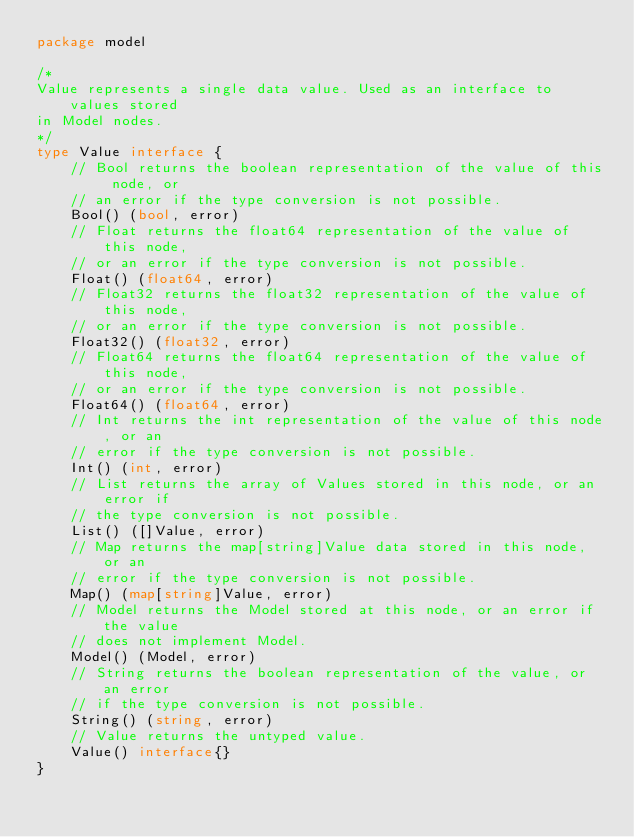<code> <loc_0><loc_0><loc_500><loc_500><_Go_>package model

/*
Value represents a single data value. Used as an interface to values stored
in Model nodes.
*/
type Value interface {
	// Bool returns the boolean representation of the value of this node, or
	// an error if the type conversion is not possible.
	Bool() (bool, error)
	// Float returns the float64 representation of the value of this node,
	// or an error if the type conversion is not possible.
	Float() (float64, error)
	// Float32 returns the float32 representation of the value of this node,
	// or an error if the type conversion is not possible.
	Float32() (float32, error)
	// Float64 returns the float64 representation of the value of this node,
	// or an error if the type conversion is not possible.
	Float64() (float64, error)
	// Int returns the int representation of the value of this node, or an
	// error if the type conversion is not possible.
	Int() (int, error)
	// List returns the array of Values stored in this node, or an error if
	// the type conversion is not possible.
	List() ([]Value, error)
	// Map returns the map[string]Value data stored in this node, or an
	// error if the type conversion is not possible.
	Map() (map[string]Value, error)
	// Model returns the Model stored at this node, or an error if the value
	// does not implement Model.
	Model() (Model, error)
	// String returns the boolean representation of the value, or an error
	// if the type conversion is not possible.
	String() (string, error)
	// Value returns the untyped value.
	Value() interface{}
}
</code> 